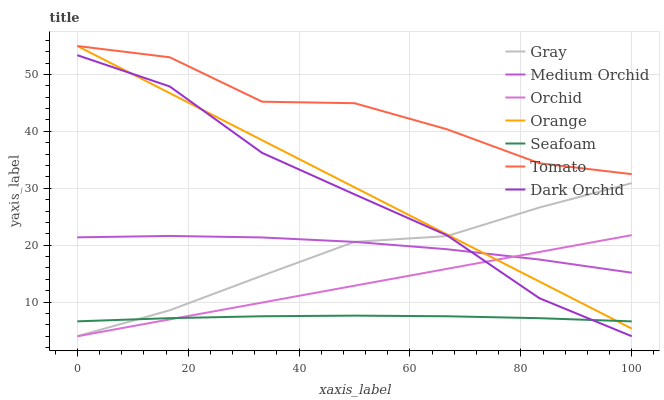Does Gray have the minimum area under the curve?
Answer yes or no. No. Does Gray have the maximum area under the curve?
Answer yes or no. No. Is Gray the smoothest?
Answer yes or no. No. Is Gray the roughest?
Answer yes or no. No. Does Medium Orchid have the lowest value?
Answer yes or no. No. Does Gray have the highest value?
Answer yes or no. No. Is Seafoam less than Tomato?
Answer yes or no. Yes. Is Tomato greater than Gray?
Answer yes or no. Yes. Does Seafoam intersect Tomato?
Answer yes or no. No. 